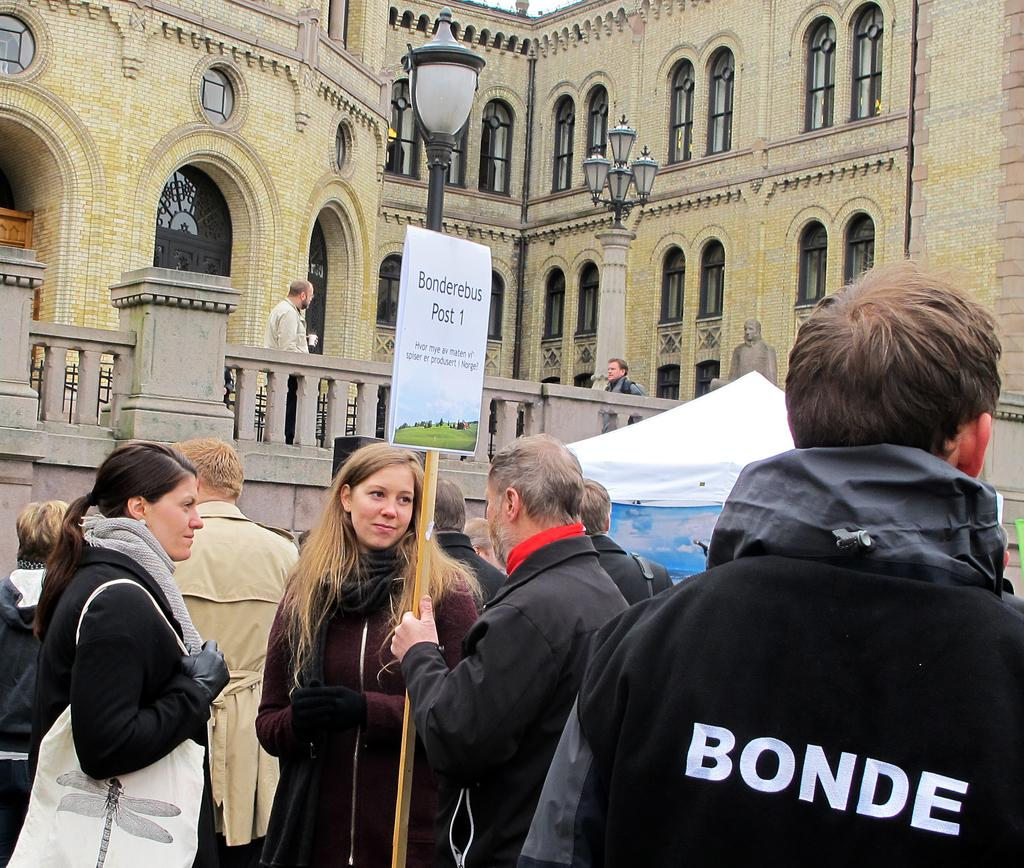How many people are in the image? There is a group of persons in the image. Where are the persons located in relation to the compound wall? The persons are standing near a compound wall. What is the compound wall a part of? The compound wall is part of a building. What can be seen in the background of the image? There is a building and a statue of a man in the background of the image. How many balloons are being held by the persons in the image? There is no mention of balloons in the image; the persons are not holding any balloons. What type of rose is growing on the compound wall? There is no rose present on the compound wall in the image. 